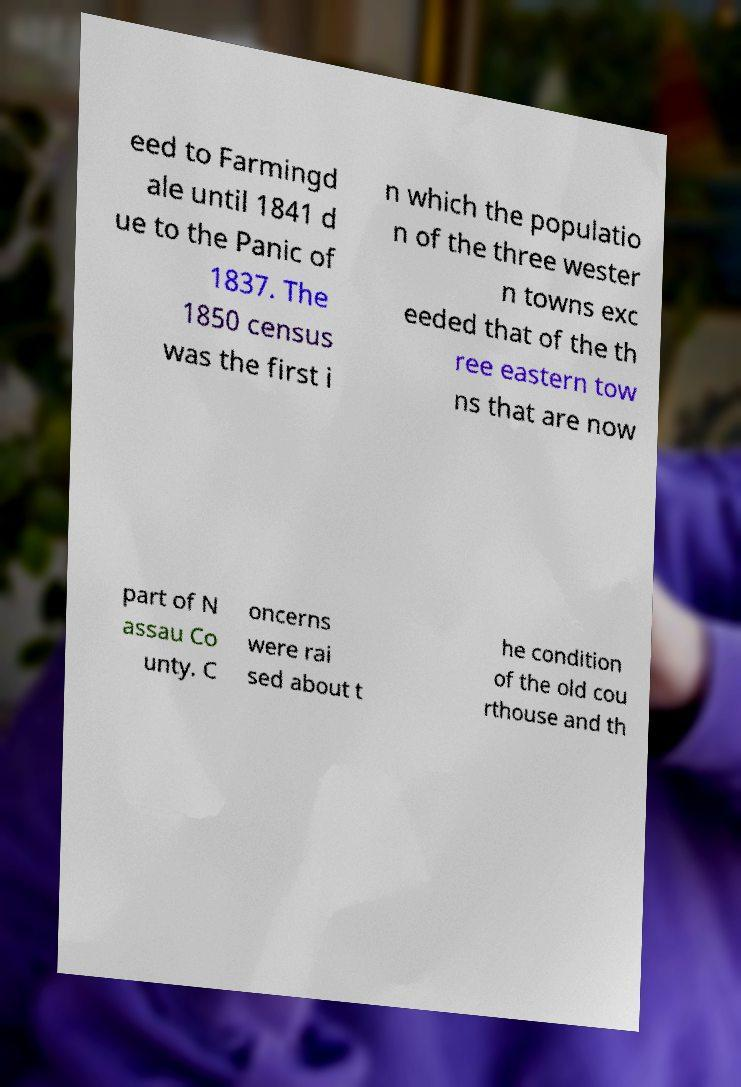There's text embedded in this image that I need extracted. Can you transcribe it verbatim? eed to Farmingd ale until 1841 d ue to the Panic of 1837. The 1850 census was the first i n which the populatio n of the three wester n towns exc eeded that of the th ree eastern tow ns that are now part of N assau Co unty. C oncerns were rai sed about t he condition of the old cou rthouse and th 